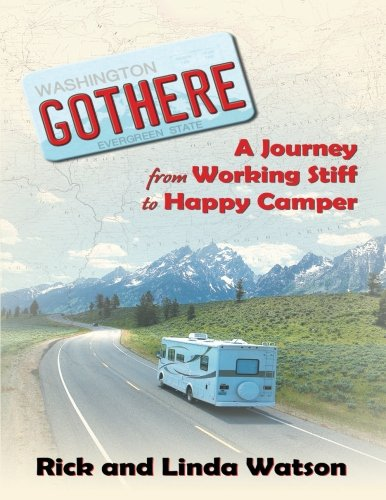Is this a homosexuality book? No, there is no indication on the book cover or in the visible title and subtitle that the book deals with topics of homosexuality. It appears to focus on travel and personal experiences. 